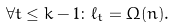<formula> <loc_0><loc_0><loc_500><loc_500>\forall t \leq k - 1 \colon \ell _ { t } = \Omega ( n ) .</formula> 